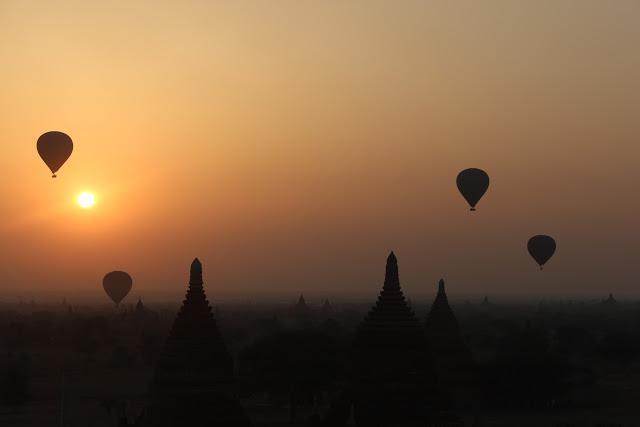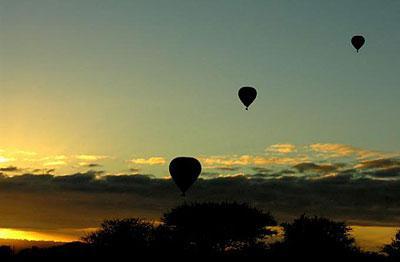The first image is the image on the left, the second image is the image on the right. Examine the images to the left and right. Is the description "At least one image has exactly three balloons." accurate? Answer yes or no. Yes. The first image is the image on the left, the second image is the image on the right. Assess this claim about the two images: "There are three hot air balloons.". Correct or not? Answer yes or no. No. 